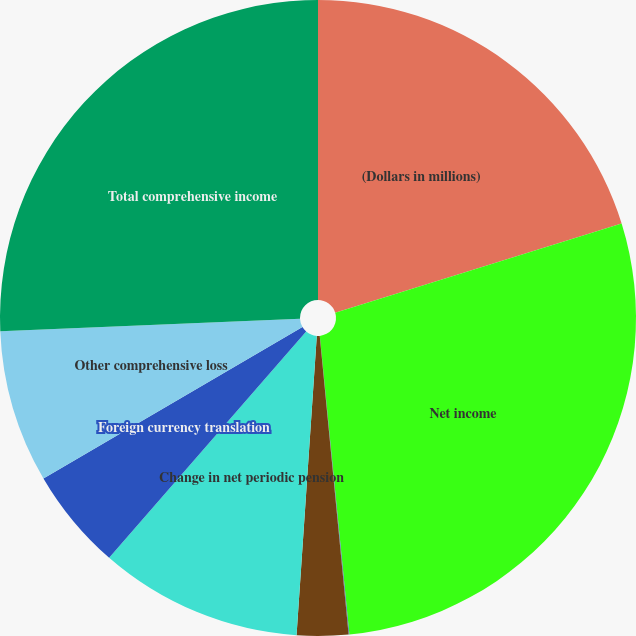Convert chart to OTSL. <chart><loc_0><loc_0><loc_500><loc_500><pie_chart><fcel>(Dollars in millions)<fcel>Net income<fcel>Change in net unrealized<fcel>Change in non-credit component<fcel>Change in net periodic pension<fcel>Foreign currency translation<fcel>Other comprehensive loss<fcel>Total comprehensive income<nl><fcel>20.2%<fcel>28.23%<fcel>0.04%<fcel>2.61%<fcel>10.33%<fcel>5.18%<fcel>7.76%<fcel>25.66%<nl></chart> 